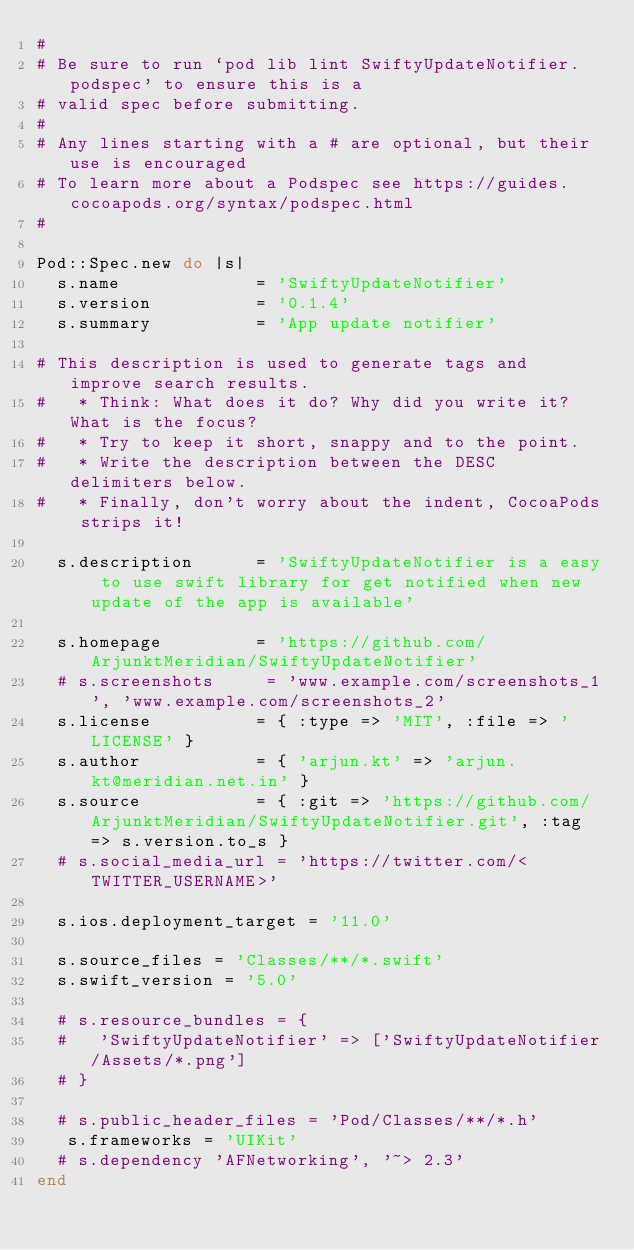<code> <loc_0><loc_0><loc_500><loc_500><_Ruby_>#
# Be sure to run `pod lib lint SwiftyUpdateNotifier.podspec' to ensure this is a
# valid spec before submitting.
#
# Any lines starting with a # are optional, but their use is encouraged
# To learn more about a Podspec see https://guides.cocoapods.org/syntax/podspec.html
#

Pod::Spec.new do |s|
  s.name             = 'SwiftyUpdateNotifier'
  s.version          = '0.1.4'
  s.summary          = 'App update notifier'

# This description is used to generate tags and improve search results.
#   * Think: What does it do? Why did you write it? What is the focus?
#   * Try to keep it short, snappy and to the point.
#   * Write the description between the DESC delimiters below.
#   * Finally, don't worry about the indent, CocoaPods strips it!

  s.description      = 'SwiftyUpdateNotifier is a easy to use swift library for get notified when new update of the app is available'

  s.homepage         = 'https://github.com/ArjunktMeridian/SwiftyUpdateNotifier'
  # s.screenshots     = 'www.example.com/screenshots_1', 'www.example.com/screenshots_2'
  s.license          = { :type => 'MIT', :file => 'LICENSE' }
  s.author           = { 'arjun.kt' => 'arjun.kt@meridian.net.in' }
  s.source           = { :git => 'https://github.com/ArjunktMeridian/SwiftyUpdateNotifier.git', :tag => s.version.to_s }
  # s.social_media_url = 'https://twitter.com/<TWITTER_USERNAME>'

  s.ios.deployment_target = '11.0'

  s.source_files = 'Classes/**/*.swift'
  s.swift_version = '5.0'
  
  # s.resource_bundles = {
  #   'SwiftyUpdateNotifier' => ['SwiftyUpdateNotifier/Assets/*.png']
  # }

  # s.public_header_files = 'Pod/Classes/**/*.h'
   s.frameworks = 'UIKit'
  # s.dependency 'AFNetworking', '~> 2.3'
end
</code> 